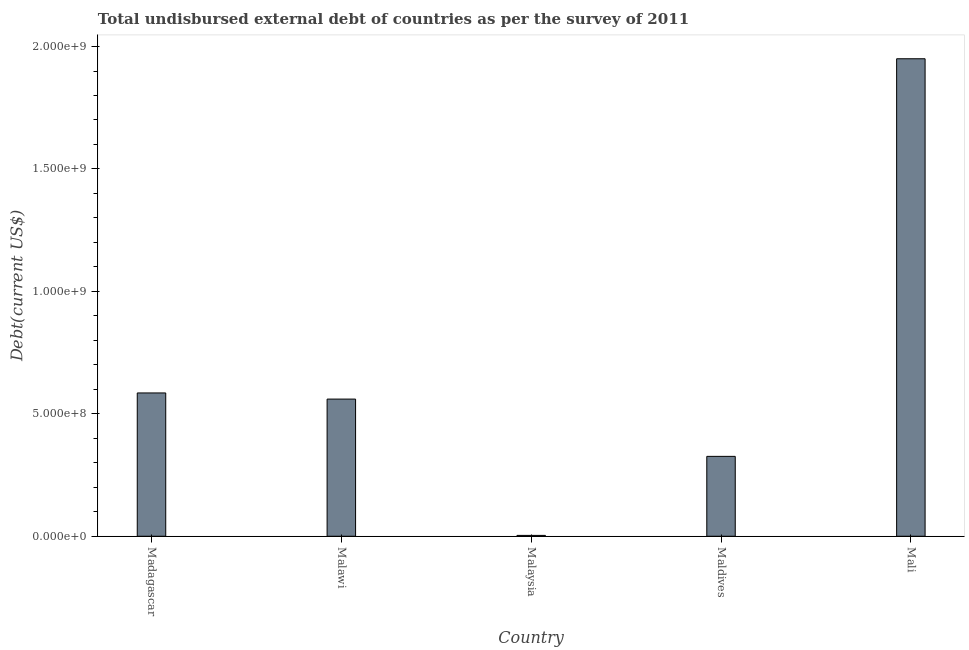Does the graph contain grids?
Offer a very short reply. No. What is the title of the graph?
Your answer should be very brief. Total undisbursed external debt of countries as per the survey of 2011. What is the label or title of the Y-axis?
Keep it short and to the point. Debt(current US$). What is the total debt in Madagascar?
Your answer should be very brief. 5.85e+08. Across all countries, what is the maximum total debt?
Keep it short and to the point. 1.95e+09. Across all countries, what is the minimum total debt?
Offer a terse response. 3.48e+06. In which country was the total debt maximum?
Provide a short and direct response. Mali. In which country was the total debt minimum?
Offer a very short reply. Malaysia. What is the sum of the total debt?
Your answer should be very brief. 3.43e+09. What is the difference between the total debt in Maldives and Mali?
Offer a terse response. -1.62e+09. What is the average total debt per country?
Give a very brief answer. 6.85e+08. What is the median total debt?
Provide a short and direct response. 5.60e+08. What is the ratio of the total debt in Malawi to that in Maldives?
Offer a very short reply. 1.72. Is the difference between the total debt in Madagascar and Malaysia greater than the difference between any two countries?
Your response must be concise. No. What is the difference between the highest and the second highest total debt?
Give a very brief answer. 1.36e+09. What is the difference between the highest and the lowest total debt?
Your answer should be compact. 1.95e+09. How many bars are there?
Keep it short and to the point. 5. How many countries are there in the graph?
Your answer should be compact. 5. What is the difference between two consecutive major ticks on the Y-axis?
Your response must be concise. 5.00e+08. What is the Debt(current US$) in Madagascar?
Provide a succinct answer. 5.85e+08. What is the Debt(current US$) in Malawi?
Your answer should be very brief. 5.60e+08. What is the Debt(current US$) of Malaysia?
Keep it short and to the point. 3.48e+06. What is the Debt(current US$) in Maldives?
Ensure brevity in your answer.  3.26e+08. What is the Debt(current US$) in Mali?
Provide a short and direct response. 1.95e+09. What is the difference between the Debt(current US$) in Madagascar and Malawi?
Your answer should be very brief. 2.50e+07. What is the difference between the Debt(current US$) in Madagascar and Malaysia?
Your answer should be compact. 5.82e+08. What is the difference between the Debt(current US$) in Madagascar and Maldives?
Keep it short and to the point. 2.59e+08. What is the difference between the Debt(current US$) in Madagascar and Mali?
Offer a very short reply. -1.36e+09. What is the difference between the Debt(current US$) in Malawi and Malaysia?
Your answer should be compact. 5.57e+08. What is the difference between the Debt(current US$) in Malawi and Maldives?
Ensure brevity in your answer.  2.34e+08. What is the difference between the Debt(current US$) in Malawi and Mali?
Offer a terse response. -1.39e+09. What is the difference between the Debt(current US$) in Malaysia and Maldives?
Make the answer very short. -3.23e+08. What is the difference between the Debt(current US$) in Malaysia and Mali?
Keep it short and to the point. -1.95e+09. What is the difference between the Debt(current US$) in Maldives and Mali?
Provide a succinct answer. -1.62e+09. What is the ratio of the Debt(current US$) in Madagascar to that in Malawi?
Ensure brevity in your answer.  1.04. What is the ratio of the Debt(current US$) in Madagascar to that in Malaysia?
Your response must be concise. 168.17. What is the ratio of the Debt(current US$) in Madagascar to that in Maldives?
Offer a terse response. 1.79. What is the ratio of the Debt(current US$) in Malawi to that in Malaysia?
Offer a terse response. 160.98. What is the ratio of the Debt(current US$) in Malawi to that in Maldives?
Make the answer very short. 1.72. What is the ratio of the Debt(current US$) in Malawi to that in Mali?
Keep it short and to the point. 0.29. What is the ratio of the Debt(current US$) in Malaysia to that in Maldives?
Make the answer very short. 0.01. What is the ratio of the Debt(current US$) in Malaysia to that in Mali?
Offer a very short reply. 0. What is the ratio of the Debt(current US$) in Maldives to that in Mali?
Provide a succinct answer. 0.17. 